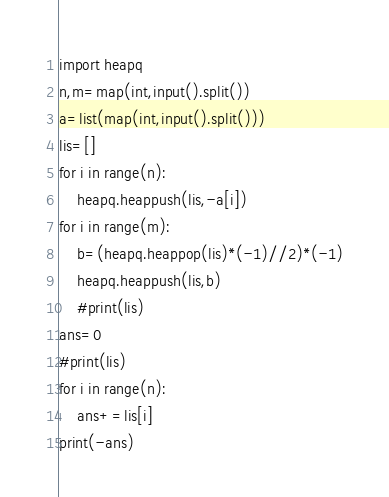<code> <loc_0><loc_0><loc_500><loc_500><_Python_>import heapq
n,m=map(int,input().split())
a=list(map(int,input().split()))
lis=[]
for i in range(n):
    heapq.heappush(lis,-a[i])
for i in range(m):
    b=(heapq.heappop(lis)*(-1)//2)*(-1)
    heapq.heappush(lis,b)
    #print(lis)
ans=0
#print(lis)
for i in range(n):
    ans+=lis[i]
print(-ans)</code> 